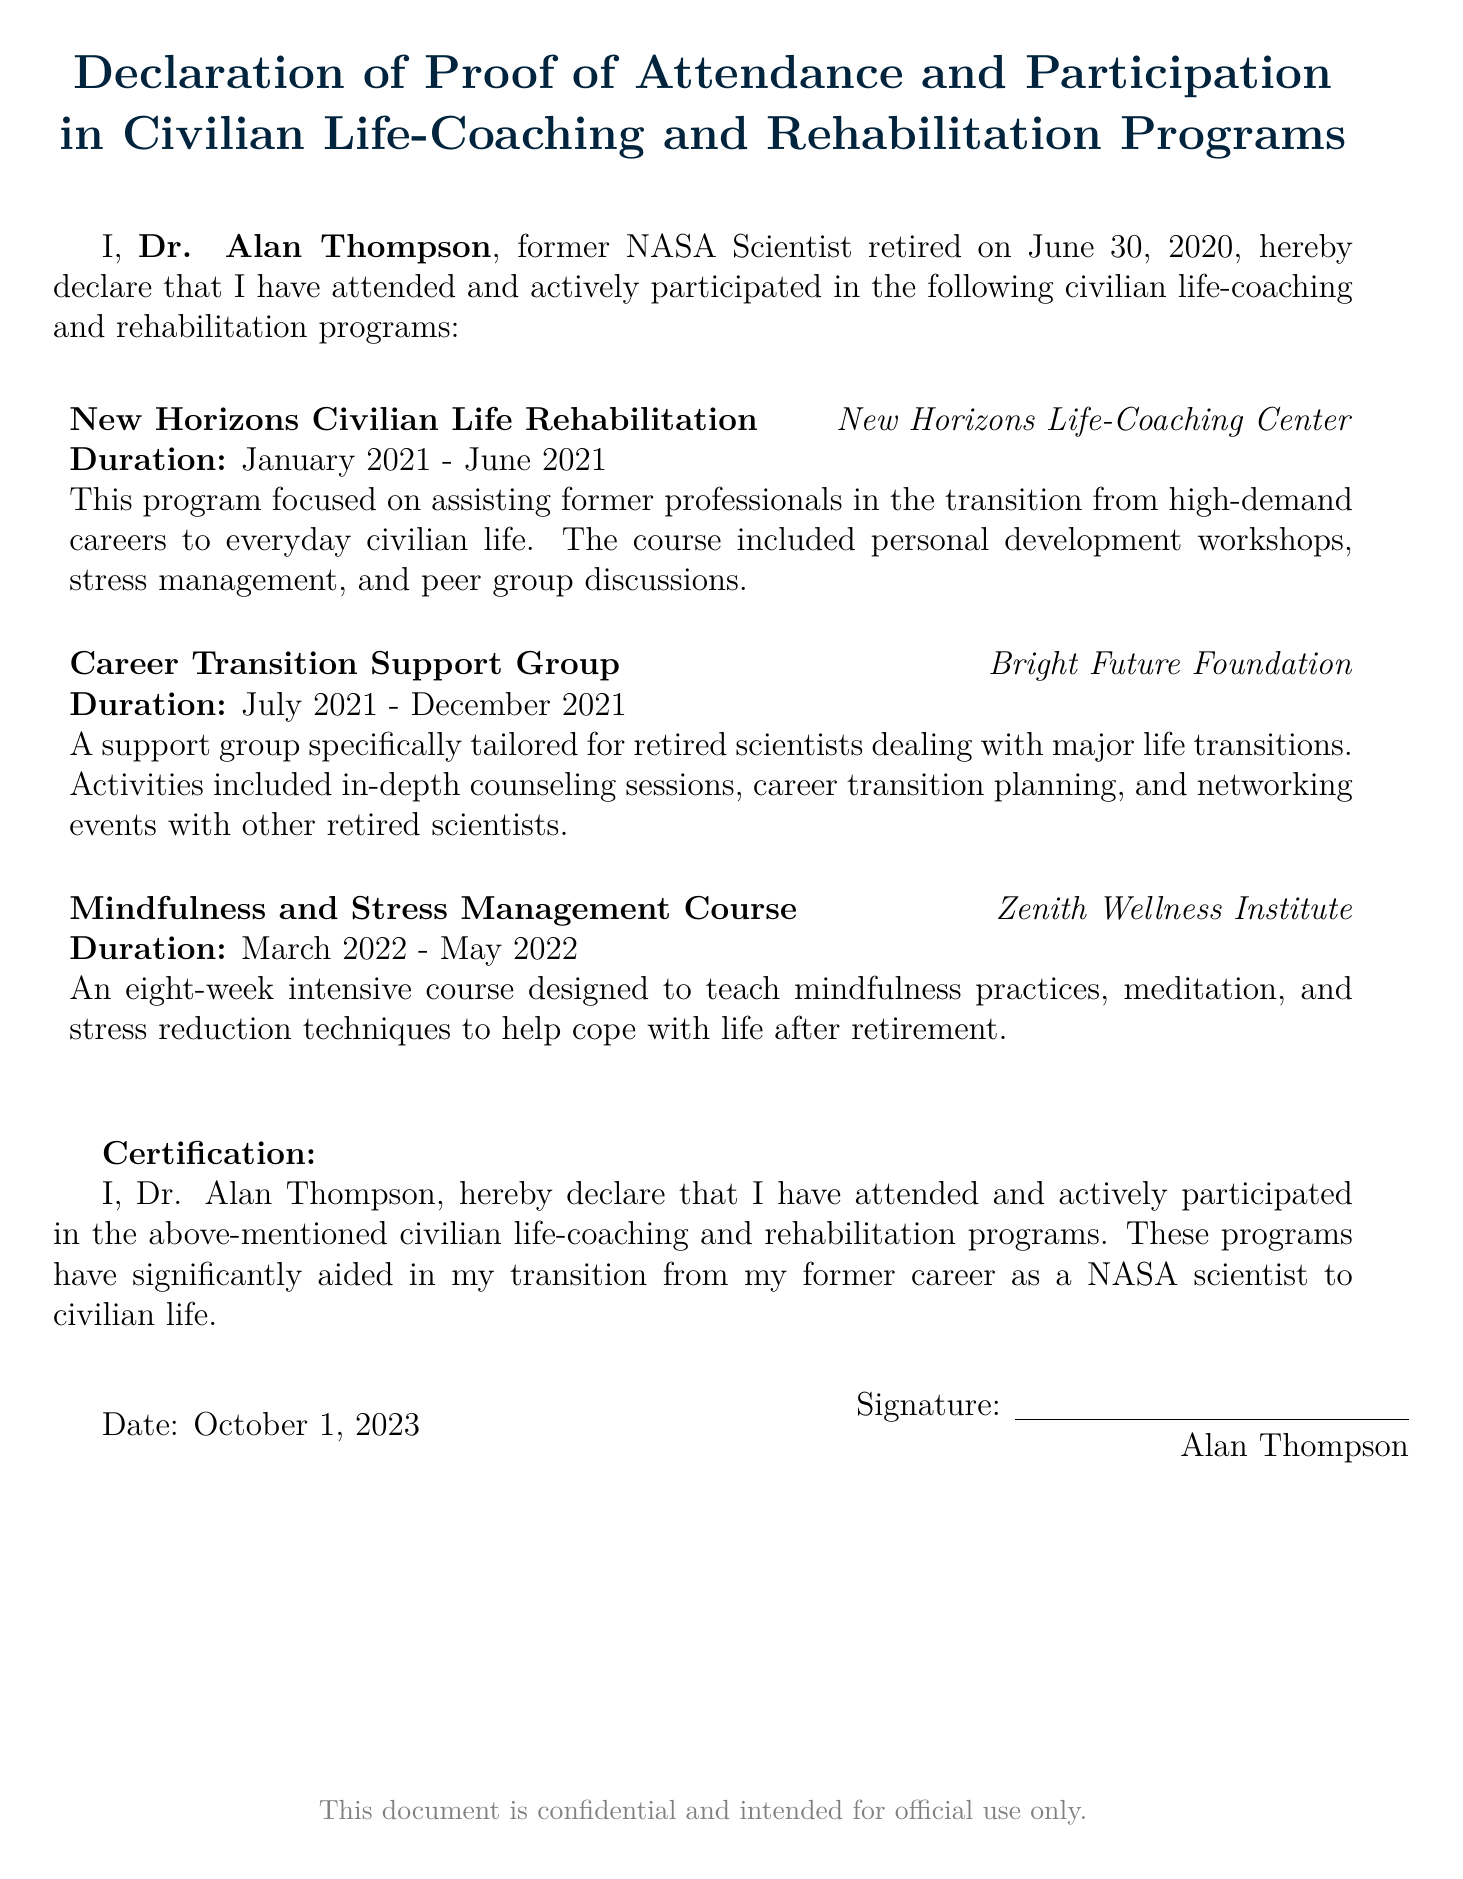What is the name of the declarant? The declarant is the person signing the document, which is Dr. Alan Thompson.
Answer: Dr. Alan Thompson When did Dr. Alan Thompson retire? The retirement date mentioned in the document is specifically stated.
Answer: June 30, 2020 What is the name of the first program listed? The first program is mentioned at the start of the list of programs.
Answer: New Horizons Civilian Life Rehabilitation How long did the Career Transition Support Group run? The duration is explicitly provided in the program's details.
Answer: July 2021 - December 2021 What type of course is the third program? The document classifies the third program under a specific category.
Answer: Mindfulness and Stress Management Course What is the certification statement in the document? The main purpose of the declaration is summarized in the certification section.
Answer: I hereby declare that I have attended and actively participated in the above-mentioned civilian life-coaching and rehabilitation programs Which organization conducted the Mindfulness and Stress Management Course? The specific institution that offered the course is mentioned in the program details.
Answer: Zenith Wellness Institute What date is the document signed? The signing date is provided towards the end of the document.
Answer: October 1, 2023 